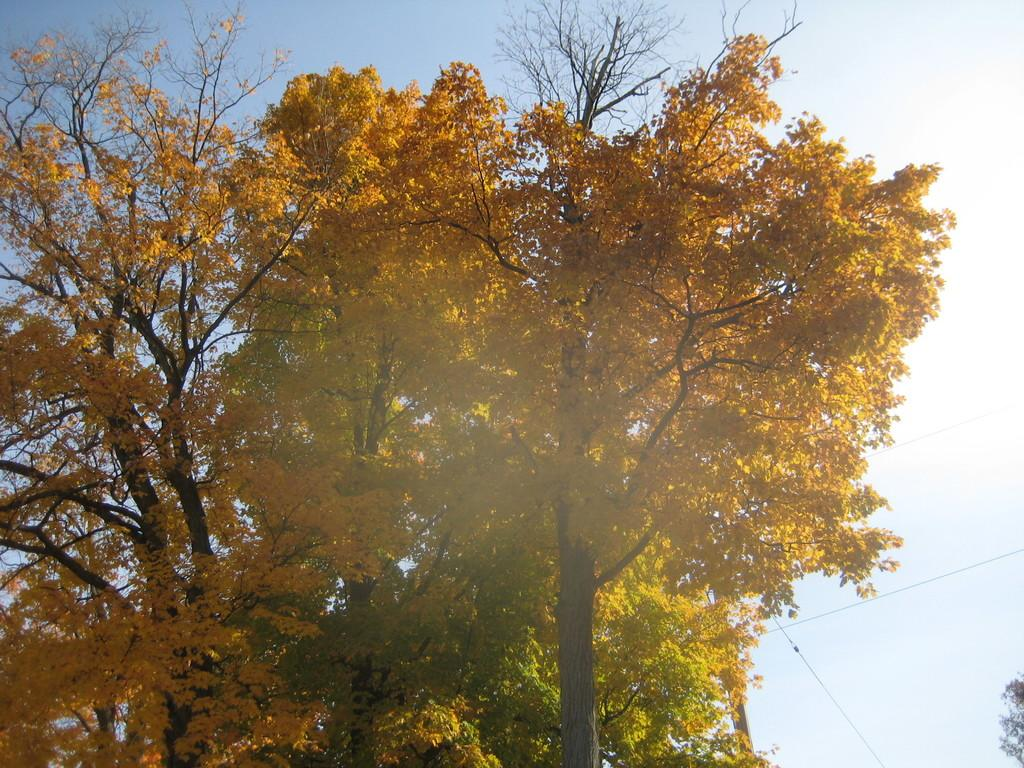What type of natural elements can be seen in the image? There are trees in the image. What man-made objects can be seen in the image? There are cables in the image. What type of debt is being discussed in the image? There is no mention or indication of any debt in the image; it features trees and cables. What hobbies are the people in the image engaged in? There are no people present in the image, so it is not possible to determine what hobbies they might be engaged in. 